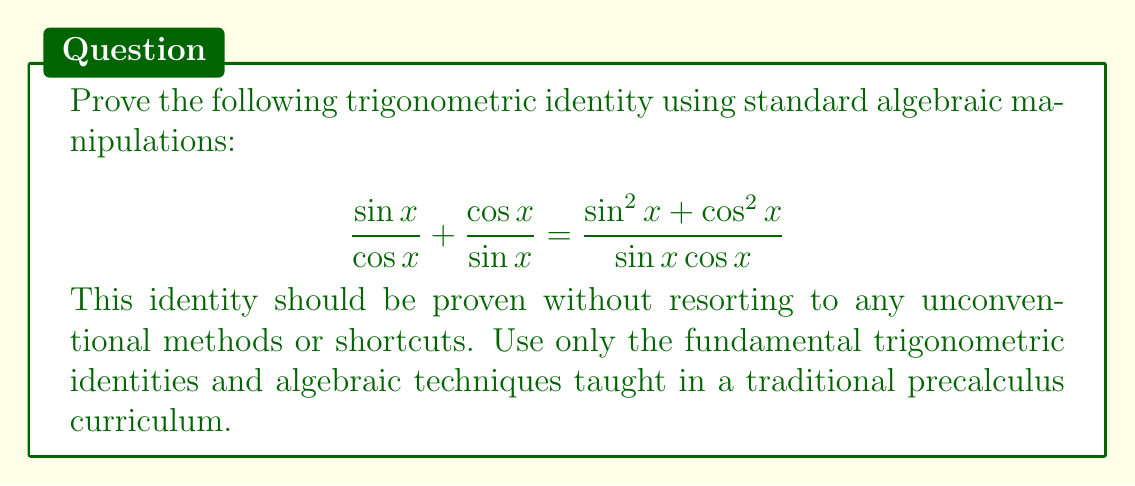Show me your answer to this math problem. Let's approach this proof using standard algebraic manipulations:

1) First, let's start with the left side of the equation:
   $$ \frac{\sin x}{\cos x} + \frac{\cos x}{\sin x} $$

2) To add these fractions, we need a common denominator. The common denominator will be $\sin x \cos x$:
   $$ \frac{\sin x \cdot \sin x}{\cos x \cdot \sin x} + \frac{\cos x \cdot \cos x}{\sin x \cdot \cos x} $$

3) This simplifies to:
   $$ \frac{\sin^2 x}{\sin x \cos x} + \frac{\cos^2 x}{\sin x \cos x} $$

4) Now we have a common denominator, so we can add the numerators:
   $$ \frac{\sin^2 x + \cos^2 x}{\sin x \cos x} $$

5) This is exactly the right side of the original equation, thus proving the identity.

Note: We didn't use any shortcuts or unconventional methods. We simply used basic algebraic manipulation and the properties of fractions, which are standard techniques in precalculus.
Answer: The identity is proven. The left side $\frac{\sin x}{\cos x} + \frac{\cos x}{\sin x}$ is equal to the right side $\frac{\sin^2 x + \cos^2 x}{\sin x \cos x}$. 